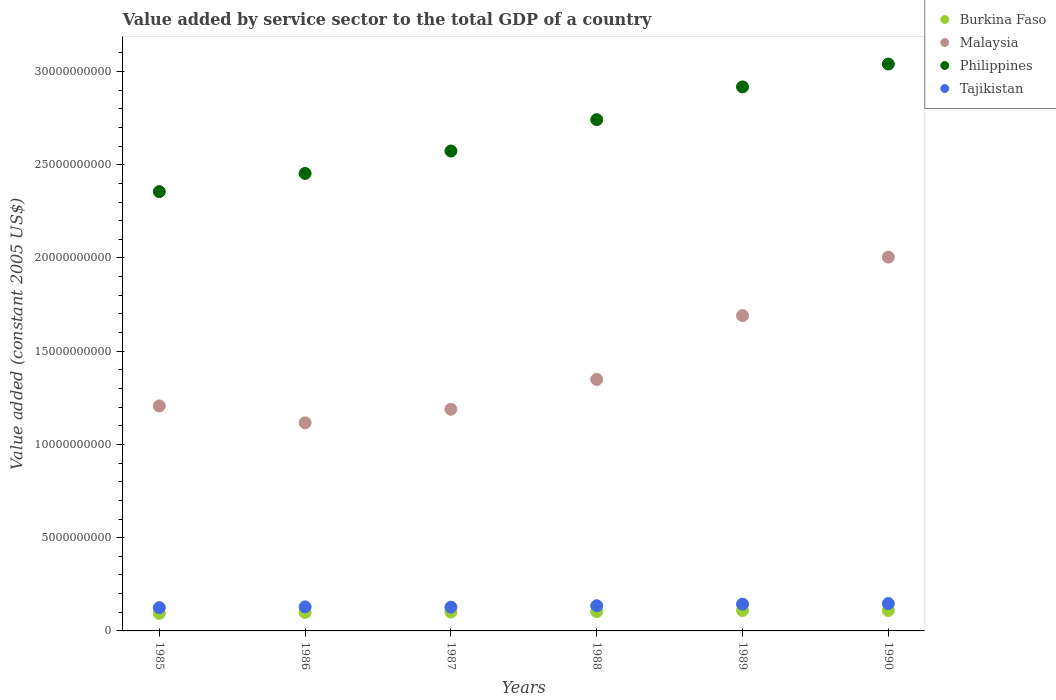Is the number of dotlines equal to the number of legend labels?
Your answer should be very brief. Yes. What is the value added by service sector in Philippines in 1985?
Provide a short and direct response. 2.36e+1. Across all years, what is the maximum value added by service sector in Philippines?
Offer a terse response. 3.04e+1. Across all years, what is the minimum value added by service sector in Tajikistan?
Your response must be concise. 1.25e+09. In which year was the value added by service sector in Tajikistan maximum?
Your answer should be compact. 1990. In which year was the value added by service sector in Philippines minimum?
Ensure brevity in your answer.  1985. What is the total value added by service sector in Burkina Faso in the graph?
Ensure brevity in your answer.  6.17e+09. What is the difference between the value added by service sector in Philippines in 1985 and that in 1989?
Your answer should be compact. -5.62e+09. What is the difference between the value added by service sector in Tajikistan in 1985 and the value added by service sector in Philippines in 1988?
Offer a terse response. -2.62e+1. What is the average value added by service sector in Tajikistan per year?
Provide a short and direct response. 1.34e+09. In the year 1988, what is the difference between the value added by service sector in Tajikistan and value added by service sector in Philippines?
Offer a terse response. -2.61e+1. In how many years, is the value added by service sector in Burkina Faso greater than 13000000000 US$?
Your response must be concise. 0. What is the ratio of the value added by service sector in Philippines in 1986 to that in 1987?
Provide a short and direct response. 0.95. Is the value added by service sector in Malaysia in 1985 less than that in 1990?
Your answer should be very brief. Yes. What is the difference between the highest and the second highest value added by service sector in Malaysia?
Make the answer very short. 3.14e+09. What is the difference between the highest and the lowest value added by service sector in Philippines?
Offer a terse response. 6.84e+09. Is it the case that in every year, the sum of the value added by service sector in Philippines and value added by service sector in Burkina Faso  is greater than the value added by service sector in Malaysia?
Give a very brief answer. Yes. Does the value added by service sector in Tajikistan monotonically increase over the years?
Your answer should be very brief. No. How many years are there in the graph?
Keep it short and to the point. 6. What is the difference between two consecutive major ticks on the Y-axis?
Provide a succinct answer. 5.00e+09. How many legend labels are there?
Give a very brief answer. 4. How are the legend labels stacked?
Your answer should be compact. Vertical. What is the title of the graph?
Make the answer very short. Value added by service sector to the total GDP of a country. Does "New Caledonia" appear as one of the legend labels in the graph?
Keep it short and to the point. No. What is the label or title of the Y-axis?
Your answer should be compact. Value added (constant 2005 US$). What is the Value added (constant 2005 US$) in Burkina Faso in 1985?
Offer a terse response. 9.41e+08. What is the Value added (constant 2005 US$) of Malaysia in 1985?
Ensure brevity in your answer.  1.21e+1. What is the Value added (constant 2005 US$) of Philippines in 1985?
Your answer should be compact. 2.36e+1. What is the Value added (constant 2005 US$) of Tajikistan in 1985?
Provide a short and direct response. 1.25e+09. What is the Value added (constant 2005 US$) in Burkina Faso in 1986?
Provide a succinct answer. 9.91e+08. What is the Value added (constant 2005 US$) of Malaysia in 1986?
Your response must be concise. 1.12e+1. What is the Value added (constant 2005 US$) in Philippines in 1986?
Ensure brevity in your answer.  2.45e+1. What is the Value added (constant 2005 US$) of Tajikistan in 1986?
Offer a terse response. 1.29e+09. What is the Value added (constant 2005 US$) in Burkina Faso in 1987?
Keep it short and to the point. 1.01e+09. What is the Value added (constant 2005 US$) in Malaysia in 1987?
Provide a succinct answer. 1.19e+1. What is the Value added (constant 2005 US$) of Philippines in 1987?
Keep it short and to the point. 2.57e+1. What is the Value added (constant 2005 US$) of Tajikistan in 1987?
Offer a very short reply. 1.28e+09. What is the Value added (constant 2005 US$) of Burkina Faso in 1988?
Keep it short and to the point. 1.04e+09. What is the Value added (constant 2005 US$) of Malaysia in 1988?
Give a very brief answer. 1.35e+1. What is the Value added (constant 2005 US$) in Philippines in 1988?
Ensure brevity in your answer.  2.74e+1. What is the Value added (constant 2005 US$) of Tajikistan in 1988?
Provide a succinct answer. 1.35e+09. What is the Value added (constant 2005 US$) of Burkina Faso in 1989?
Provide a short and direct response. 1.09e+09. What is the Value added (constant 2005 US$) in Malaysia in 1989?
Your answer should be compact. 1.69e+1. What is the Value added (constant 2005 US$) of Philippines in 1989?
Your answer should be very brief. 2.92e+1. What is the Value added (constant 2005 US$) in Tajikistan in 1989?
Give a very brief answer. 1.44e+09. What is the Value added (constant 2005 US$) of Burkina Faso in 1990?
Provide a short and direct response. 1.09e+09. What is the Value added (constant 2005 US$) in Malaysia in 1990?
Give a very brief answer. 2.00e+1. What is the Value added (constant 2005 US$) of Philippines in 1990?
Offer a terse response. 3.04e+1. What is the Value added (constant 2005 US$) in Tajikistan in 1990?
Your answer should be compact. 1.47e+09. Across all years, what is the maximum Value added (constant 2005 US$) in Burkina Faso?
Offer a terse response. 1.09e+09. Across all years, what is the maximum Value added (constant 2005 US$) in Malaysia?
Provide a short and direct response. 2.00e+1. Across all years, what is the maximum Value added (constant 2005 US$) of Philippines?
Provide a short and direct response. 3.04e+1. Across all years, what is the maximum Value added (constant 2005 US$) in Tajikistan?
Provide a succinct answer. 1.47e+09. Across all years, what is the minimum Value added (constant 2005 US$) in Burkina Faso?
Your answer should be compact. 9.41e+08. Across all years, what is the minimum Value added (constant 2005 US$) in Malaysia?
Your answer should be very brief. 1.12e+1. Across all years, what is the minimum Value added (constant 2005 US$) in Philippines?
Provide a succinct answer. 2.36e+1. Across all years, what is the minimum Value added (constant 2005 US$) in Tajikistan?
Make the answer very short. 1.25e+09. What is the total Value added (constant 2005 US$) in Burkina Faso in the graph?
Your answer should be very brief. 6.17e+09. What is the total Value added (constant 2005 US$) of Malaysia in the graph?
Give a very brief answer. 8.56e+1. What is the total Value added (constant 2005 US$) in Philippines in the graph?
Make the answer very short. 1.61e+11. What is the total Value added (constant 2005 US$) of Tajikistan in the graph?
Give a very brief answer. 8.07e+09. What is the difference between the Value added (constant 2005 US$) in Burkina Faso in 1985 and that in 1986?
Offer a very short reply. -4.99e+07. What is the difference between the Value added (constant 2005 US$) of Malaysia in 1985 and that in 1986?
Make the answer very short. 9.03e+08. What is the difference between the Value added (constant 2005 US$) of Philippines in 1985 and that in 1986?
Your answer should be compact. -9.74e+08. What is the difference between the Value added (constant 2005 US$) of Tajikistan in 1985 and that in 1986?
Make the answer very short. -4.25e+07. What is the difference between the Value added (constant 2005 US$) of Burkina Faso in 1985 and that in 1987?
Offer a very short reply. -7.12e+07. What is the difference between the Value added (constant 2005 US$) in Malaysia in 1985 and that in 1987?
Ensure brevity in your answer.  1.76e+08. What is the difference between the Value added (constant 2005 US$) in Philippines in 1985 and that in 1987?
Your answer should be very brief. -2.18e+09. What is the difference between the Value added (constant 2005 US$) of Tajikistan in 1985 and that in 1987?
Your response must be concise. -2.70e+07. What is the difference between the Value added (constant 2005 US$) of Burkina Faso in 1985 and that in 1988?
Give a very brief answer. -9.63e+07. What is the difference between the Value added (constant 2005 US$) of Malaysia in 1985 and that in 1988?
Your response must be concise. -1.42e+09. What is the difference between the Value added (constant 2005 US$) of Philippines in 1985 and that in 1988?
Your answer should be very brief. -3.86e+09. What is the difference between the Value added (constant 2005 US$) of Tajikistan in 1985 and that in 1988?
Offer a terse response. -1.01e+08. What is the difference between the Value added (constant 2005 US$) of Burkina Faso in 1985 and that in 1989?
Your response must be concise. -1.53e+08. What is the difference between the Value added (constant 2005 US$) of Malaysia in 1985 and that in 1989?
Offer a terse response. -4.85e+09. What is the difference between the Value added (constant 2005 US$) in Philippines in 1985 and that in 1989?
Keep it short and to the point. -5.62e+09. What is the difference between the Value added (constant 2005 US$) in Tajikistan in 1985 and that in 1989?
Keep it short and to the point. -1.87e+08. What is the difference between the Value added (constant 2005 US$) of Burkina Faso in 1985 and that in 1990?
Give a very brief answer. -1.51e+08. What is the difference between the Value added (constant 2005 US$) of Malaysia in 1985 and that in 1990?
Your response must be concise. -7.98e+09. What is the difference between the Value added (constant 2005 US$) in Philippines in 1985 and that in 1990?
Provide a short and direct response. -6.84e+09. What is the difference between the Value added (constant 2005 US$) of Tajikistan in 1985 and that in 1990?
Your answer should be compact. -2.19e+08. What is the difference between the Value added (constant 2005 US$) in Burkina Faso in 1986 and that in 1987?
Your response must be concise. -2.14e+07. What is the difference between the Value added (constant 2005 US$) in Malaysia in 1986 and that in 1987?
Ensure brevity in your answer.  -7.26e+08. What is the difference between the Value added (constant 2005 US$) in Philippines in 1986 and that in 1987?
Your response must be concise. -1.20e+09. What is the difference between the Value added (constant 2005 US$) in Tajikistan in 1986 and that in 1987?
Provide a succinct answer. 1.55e+07. What is the difference between the Value added (constant 2005 US$) of Burkina Faso in 1986 and that in 1988?
Provide a short and direct response. -4.64e+07. What is the difference between the Value added (constant 2005 US$) of Malaysia in 1986 and that in 1988?
Ensure brevity in your answer.  -2.33e+09. What is the difference between the Value added (constant 2005 US$) in Philippines in 1986 and that in 1988?
Keep it short and to the point. -2.88e+09. What is the difference between the Value added (constant 2005 US$) in Tajikistan in 1986 and that in 1988?
Give a very brief answer. -5.85e+07. What is the difference between the Value added (constant 2005 US$) in Burkina Faso in 1986 and that in 1989?
Your answer should be very brief. -1.03e+08. What is the difference between the Value added (constant 2005 US$) in Malaysia in 1986 and that in 1989?
Ensure brevity in your answer.  -5.75e+09. What is the difference between the Value added (constant 2005 US$) in Philippines in 1986 and that in 1989?
Your answer should be compact. -4.64e+09. What is the difference between the Value added (constant 2005 US$) of Tajikistan in 1986 and that in 1989?
Give a very brief answer. -1.45e+08. What is the difference between the Value added (constant 2005 US$) in Burkina Faso in 1986 and that in 1990?
Your answer should be very brief. -1.02e+08. What is the difference between the Value added (constant 2005 US$) of Malaysia in 1986 and that in 1990?
Make the answer very short. -8.89e+09. What is the difference between the Value added (constant 2005 US$) of Philippines in 1986 and that in 1990?
Provide a short and direct response. -5.87e+09. What is the difference between the Value added (constant 2005 US$) in Tajikistan in 1986 and that in 1990?
Provide a short and direct response. -1.76e+08. What is the difference between the Value added (constant 2005 US$) of Burkina Faso in 1987 and that in 1988?
Your response must be concise. -2.50e+07. What is the difference between the Value added (constant 2005 US$) in Malaysia in 1987 and that in 1988?
Provide a short and direct response. -1.60e+09. What is the difference between the Value added (constant 2005 US$) in Philippines in 1987 and that in 1988?
Your response must be concise. -1.68e+09. What is the difference between the Value added (constant 2005 US$) in Tajikistan in 1987 and that in 1988?
Offer a very short reply. -7.40e+07. What is the difference between the Value added (constant 2005 US$) in Burkina Faso in 1987 and that in 1989?
Your answer should be compact. -8.15e+07. What is the difference between the Value added (constant 2005 US$) of Malaysia in 1987 and that in 1989?
Offer a very short reply. -5.02e+09. What is the difference between the Value added (constant 2005 US$) of Philippines in 1987 and that in 1989?
Ensure brevity in your answer.  -3.44e+09. What is the difference between the Value added (constant 2005 US$) in Tajikistan in 1987 and that in 1989?
Provide a short and direct response. -1.60e+08. What is the difference between the Value added (constant 2005 US$) of Burkina Faso in 1987 and that in 1990?
Provide a short and direct response. -8.02e+07. What is the difference between the Value added (constant 2005 US$) in Malaysia in 1987 and that in 1990?
Keep it short and to the point. -8.16e+09. What is the difference between the Value added (constant 2005 US$) in Philippines in 1987 and that in 1990?
Provide a short and direct response. -4.66e+09. What is the difference between the Value added (constant 2005 US$) of Tajikistan in 1987 and that in 1990?
Offer a very short reply. -1.92e+08. What is the difference between the Value added (constant 2005 US$) of Burkina Faso in 1988 and that in 1989?
Your answer should be compact. -5.65e+07. What is the difference between the Value added (constant 2005 US$) of Malaysia in 1988 and that in 1989?
Give a very brief answer. -3.42e+09. What is the difference between the Value added (constant 2005 US$) of Philippines in 1988 and that in 1989?
Give a very brief answer. -1.76e+09. What is the difference between the Value added (constant 2005 US$) in Tajikistan in 1988 and that in 1989?
Your response must be concise. -8.64e+07. What is the difference between the Value added (constant 2005 US$) of Burkina Faso in 1988 and that in 1990?
Your answer should be compact. -5.52e+07. What is the difference between the Value added (constant 2005 US$) in Malaysia in 1988 and that in 1990?
Offer a very short reply. -6.56e+09. What is the difference between the Value added (constant 2005 US$) in Philippines in 1988 and that in 1990?
Give a very brief answer. -2.98e+09. What is the difference between the Value added (constant 2005 US$) of Tajikistan in 1988 and that in 1990?
Your answer should be compact. -1.18e+08. What is the difference between the Value added (constant 2005 US$) in Burkina Faso in 1989 and that in 1990?
Your answer should be very brief. 1.32e+06. What is the difference between the Value added (constant 2005 US$) in Malaysia in 1989 and that in 1990?
Provide a succinct answer. -3.14e+09. What is the difference between the Value added (constant 2005 US$) in Philippines in 1989 and that in 1990?
Provide a short and direct response. -1.23e+09. What is the difference between the Value added (constant 2005 US$) of Tajikistan in 1989 and that in 1990?
Keep it short and to the point. -3.16e+07. What is the difference between the Value added (constant 2005 US$) in Burkina Faso in 1985 and the Value added (constant 2005 US$) in Malaysia in 1986?
Your answer should be very brief. -1.02e+1. What is the difference between the Value added (constant 2005 US$) of Burkina Faso in 1985 and the Value added (constant 2005 US$) of Philippines in 1986?
Offer a terse response. -2.36e+1. What is the difference between the Value added (constant 2005 US$) in Burkina Faso in 1985 and the Value added (constant 2005 US$) in Tajikistan in 1986?
Your response must be concise. -3.50e+08. What is the difference between the Value added (constant 2005 US$) in Malaysia in 1985 and the Value added (constant 2005 US$) in Philippines in 1986?
Your answer should be very brief. -1.25e+1. What is the difference between the Value added (constant 2005 US$) in Malaysia in 1985 and the Value added (constant 2005 US$) in Tajikistan in 1986?
Provide a succinct answer. 1.08e+1. What is the difference between the Value added (constant 2005 US$) of Philippines in 1985 and the Value added (constant 2005 US$) of Tajikistan in 1986?
Your answer should be compact. 2.23e+1. What is the difference between the Value added (constant 2005 US$) in Burkina Faso in 1985 and the Value added (constant 2005 US$) in Malaysia in 1987?
Provide a succinct answer. -1.09e+1. What is the difference between the Value added (constant 2005 US$) of Burkina Faso in 1985 and the Value added (constant 2005 US$) of Philippines in 1987?
Ensure brevity in your answer.  -2.48e+1. What is the difference between the Value added (constant 2005 US$) in Burkina Faso in 1985 and the Value added (constant 2005 US$) in Tajikistan in 1987?
Keep it short and to the point. -3.35e+08. What is the difference between the Value added (constant 2005 US$) in Malaysia in 1985 and the Value added (constant 2005 US$) in Philippines in 1987?
Make the answer very short. -1.37e+1. What is the difference between the Value added (constant 2005 US$) of Malaysia in 1985 and the Value added (constant 2005 US$) of Tajikistan in 1987?
Make the answer very short. 1.08e+1. What is the difference between the Value added (constant 2005 US$) of Philippines in 1985 and the Value added (constant 2005 US$) of Tajikistan in 1987?
Keep it short and to the point. 2.23e+1. What is the difference between the Value added (constant 2005 US$) of Burkina Faso in 1985 and the Value added (constant 2005 US$) of Malaysia in 1988?
Keep it short and to the point. -1.25e+1. What is the difference between the Value added (constant 2005 US$) of Burkina Faso in 1985 and the Value added (constant 2005 US$) of Philippines in 1988?
Offer a very short reply. -2.65e+1. What is the difference between the Value added (constant 2005 US$) of Burkina Faso in 1985 and the Value added (constant 2005 US$) of Tajikistan in 1988?
Ensure brevity in your answer.  -4.09e+08. What is the difference between the Value added (constant 2005 US$) of Malaysia in 1985 and the Value added (constant 2005 US$) of Philippines in 1988?
Offer a terse response. -1.54e+1. What is the difference between the Value added (constant 2005 US$) of Malaysia in 1985 and the Value added (constant 2005 US$) of Tajikistan in 1988?
Ensure brevity in your answer.  1.07e+1. What is the difference between the Value added (constant 2005 US$) in Philippines in 1985 and the Value added (constant 2005 US$) in Tajikistan in 1988?
Keep it short and to the point. 2.22e+1. What is the difference between the Value added (constant 2005 US$) in Burkina Faso in 1985 and the Value added (constant 2005 US$) in Malaysia in 1989?
Provide a succinct answer. -1.60e+1. What is the difference between the Value added (constant 2005 US$) of Burkina Faso in 1985 and the Value added (constant 2005 US$) of Philippines in 1989?
Your response must be concise. -2.82e+1. What is the difference between the Value added (constant 2005 US$) of Burkina Faso in 1985 and the Value added (constant 2005 US$) of Tajikistan in 1989?
Provide a short and direct response. -4.95e+08. What is the difference between the Value added (constant 2005 US$) in Malaysia in 1985 and the Value added (constant 2005 US$) in Philippines in 1989?
Your response must be concise. -1.71e+1. What is the difference between the Value added (constant 2005 US$) of Malaysia in 1985 and the Value added (constant 2005 US$) of Tajikistan in 1989?
Make the answer very short. 1.06e+1. What is the difference between the Value added (constant 2005 US$) in Philippines in 1985 and the Value added (constant 2005 US$) in Tajikistan in 1989?
Your answer should be compact. 2.21e+1. What is the difference between the Value added (constant 2005 US$) in Burkina Faso in 1985 and the Value added (constant 2005 US$) in Malaysia in 1990?
Provide a succinct answer. -1.91e+1. What is the difference between the Value added (constant 2005 US$) in Burkina Faso in 1985 and the Value added (constant 2005 US$) in Philippines in 1990?
Your answer should be compact. -2.95e+1. What is the difference between the Value added (constant 2005 US$) in Burkina Faso in 1985 and the Value added (constant 2005 US$) in Tajikistan in 1990?
Provide a short and direct response. -5.27e+08. What is the difference between the Value added (constant 2005 US$) in Malaysia in 1985 and the Value added (constant 2005 US$) in Philippines in 1990?
Make the answer very short. -1.83e+1. What is the difference between the Value added (constant 2005 US$) of Malaysia in 1985 and the Value added (constant 2005 US$) of Tajikistan in 1990?
Your answer should be very brief. 1.06e+1. What is the difference between the Value added (constant 2005 US$) in Philippines in 1985 and the Value added (constant 2005 US$) in Tajikistan in 1990?
Provide a short and direct response. 2.21e+1. What is the difference between the Value added (constant 2005 US$) in Burkina Faso in 1986 and the Value added (constant 2005 US$) in Malaysia in 1987?
Give a very brief answer. -1.09e+1. What is the difference between the Value added (constant 2005 US$) of Burkina Faso in 1986 and the Value added (constant 2005 US$) of Philippines in 1987?
Provide a succinct answer. -2.47e+1. What is the difference between the Value added (constant 2005 US$) of Burkina Faso in 1986 and the Value added (constant 2005 US$) of Tajikistan in 1987?
Provide a succinct answer. -2.85e+08. What is the difference between the Value added (constant 2005 US$) of Malaysia in 1986 and the Value added (constant 2005 US$) of Philippines in 1987?
Your response must be concise. -1.46e+1. What is the difference between the Value added (constant 2005 US$) of Malaysia in 1986 and the Value added (constant 2005 US$) of Tajikistan in 1987?
Your answer should be compact. 9.89e+09. What is the difference between the Value added (constant 2005 US$) in Philippines in 1986 and the Value added (constant 2005 US$) in Tajikistan in 1987?
Make the answer very short. 2.33e+1. What is the difference between the Value added (constant 2005 US$) of Burkina Faso in 1986 and the Value added (constant 2005 US$) of Malaysia in 1988?
Offer a very short reply. -1.25e+1. What is the difference between the Value added (constant 2005 US$) of Burkina Faso in 1986 and the Value added (constant 2005 US$) of Philippines in 1988?
Provide a succinct answer. -2.64e+1. What is the difference between the Value added (constant 2005 US$) of Burkina Faso in 1986 and the Value added (constant 2005 US$) of Tajikistan in 1988?
Your answer should be compact. -3.59e+08. What is the difference between the Value added (constant 2005 US$) in Malaysia in 1986 and the Value added (constant 2005 US$) in Philippines in 1988?
Offer a terse response. -1.63e+1. What is the difference between the Value added (constant 2005 US$) of Malaysia in 1986 and the Value added (constant 2005 US$) of Tajikistan in 1988?
Keep it short and to the point. 9.81e+09. What is the difference between the Value added (constant 2005 US$) in Philippines in 1986 and the Value added (constant 2005 US$) in Tajikistan in 1988?
Ensure brevity in your answer.  2.32e+1. What is the difference between the Value added (constant 2005 US$) in Burkina Faso in 1986 and the Value added (constant 2005 US$) in Malaysia in 1989?
Provide a short and direct response. -1.59e+1. What is the difference between the Value added (constant 2005 US$) of Burkina Faso in 1986 and the Value added (constant 2005 US$) of Philippines in 1989?
Offer a terse response. -2.82e+1. What is the difference between the Value added (constant 2005 US$) in Burkina Faso in 1986 and the Value added (constant 2005 US$) in Tajikistan in 1989?
Provide a short and direct response. -4.45e+08. What is the difference between the Value added (constant 2005 US$) in Malaysia in 1986 and the Value added (constant 2005 US$) in Philippines in 1989?
Keep it short and to the point. -1.80e+1. What is the difference between the Value added (constant 2005 US$) of Malaysia in 1986 and the Value added (constant 2005 US$) of Tajikistan in 1989?
Offer a very short reply. 9.73e+09. What is the difference between the Value added (constant 2005 US$) of Philippines in 1986 and the Value added (constant 2005 US$) of Tajikistan in 1989?
Offer a very short reply. 2.31e+1. What is the difference between the Value added (constant 2005 US$) of Burkina Faso in 1986 and the Value added (constant 2005 US$) of Malaysia in 1990?
Your answer should be compact. -1.91e+1. What is the difference between the Value added (constant 2005 US$) of Burkina Faso in 1986 and the Value added (constant 2005 US$) of Philippines in 1990?
Provide a short and direct response. -2.94e+1. What is the difference between the Value added (constant 2005 US$) of Burkina Faso in 1986 and the Value added (constant 2005 US$) of Tajikistan in 1990?
Provide a short and direct response. -4.77e+08. What is the difference between the Value added (constant 2005 US$) of Malaysia in 1986 and the Value added (constant 2005 US$) of Philippines in 1990?
Provide a succinct answer. -1.92e+1. What is the difference between the Value added (constant 2005 US$) in Malaysia in 1986 and the Value added (constant 2005 US$) in Tajikistan in 1990?
Ensure brevity in your answer.  9.69e+09. What is the difference between the Value added (constant 2005 US$) of Philippines in 1986 and the Value added (constant 2005 US$) of Tajikistan in 1990?
Your answer should be compact. 2.31e+1. What is the difference between the Value added (constant 2005 US$) in Burkina Faso in 1987 and the Value added (constant 2005 US$) in Malaysia in 1988?
Keep it short and to the point. -1.25e+1. What is the difference between the Value added (constant 2005 US$) in Burkina Faso in 1987 and the Value added (constant 2005 US$) in Philippines in 1988?
Provide a succinct answer. -2.64e+1. What is the difference between the Value added (constant 2005 US$) of Burkina Faso in 1987 and the Value added (constant 2005 US$) of Tajikistan in 1988?
Your answer should be very brief. -3.38e+08. What is the difference between the Value added (constant 2005 US$) in Malaysia in 1987 and the Value added (constant 2005 US$) in Philippines in 1988?
Make the answer very short. -1.55e+1. What is the difference between the Value added (constant 2005 US$) in Malaysia in 1987 and the Value added (constant 2005 US$) in Tajikistan in 1988?
Provide a short and direct response. 1.05e+1. What is the difference between the Value added (constant 2005 US$) in Philippines in 1987 and the Value added (constant 2005 US$) in Tajikistan in 1988?
Offer a very short reply. 2.44e+1. What is the difference between the Value added (constant 2005 US$) of Burkina Faso in 1987 and the Value added (constant 2005 US$) of Malaysia in 1989?
Give a very brief answer. -1.59e+1. What is the difference between the Value added (constant 2005 US$) in Burkina Faso in 1987 and the Value added (constant 2005 US$) in Philippines in 1989?
Provide a succinct answer. -2.82e+1. What is the difference between the Value added (constant 2005 US$) in Burkina Faso in 1987 and the Value added (constant 2005 US$) in Tajikistan in 1989?
Offer a terse response. -4.24e+08. What is the difference between the Value added (constant 2005 US$) in Malaysia in 1987 and the Value added (constant 2005 US$) in Philippines in 1989?
Your answer should be very brief. -1.73e+1. What is the difference between the Value added (constant 2005 US$) of Malaysia in 1987 and the Value added (constant 2005 US$) of Tajikistan in 1989?
Make the answer very short. 1.05e+1. What is the difference between the Value added (constant 2005 US$) in Philippines in 1987 and the Value added (constant 2005 US$) in Tajikistan in 1989?
Your response must be concise. 2.43e+1. What is the difference between the Value added (constant 2005 US$) in Burkina Faso in 1987 and the Value added (constant 2005 US$) in Malaysia in 1990?
Your answer should be very brief. -1.90e+1. What is the difference between the Value added (constant 2005 US$) of Burkina Faso in 1987 and the Value added (constant 2005 US$) of Philippines in 1990?
Your answer should be very brief. -2.94e+1. What is the difference between the Value added (constant 2005 US$) in Burkina Faso in 1987 and the Value added (constant 2005 US$) in Tajikistan in 1990?
Offer a terse response. -4.56e+08. What is the difference between the Value added (constant 2005 US$) in Malaysia in 1987 and the Value added (constant 2005 US$) in Philippines in 1990?
Your response must be concise. -1.85e+1. What is the difference between the Value added (constant 2005 US$) of Malaysia in 1987 and the Value added (constant 2005 US$) of Tajikistan in 1990?
Ensure brevity in your answer.  1.04e+1. What is the difference between the Value added (constant 2005 US$) in Philippines in 1987 and the Value added (constant 2005 US$) in Tajikistan in 1990?
Provide a short and direct response. 2.43e+1. What is the difference between the Value added (constant 2005 US$) of Burkina Faso in 1988 and the Value added (constant 2005 US$) of Malaysia in 1989?
Provide a short and direct response. -1.59e+1. What is the difference between the Value added (constant 2005 US$) of Burkina Faso in 1988 and the Value added (constant 2005 US$) of Philippines in 1989?
Provide a short and direct response. -2.81e+1. What is the difference between the Value added (constant 2005 US$) of Burkina Faso in 1988 and the Value added (constant 2005 US$) of Tajikistan in 1989?
Provide a succinct answer. -3.99e+08. What is the difference between the Value added (constant 2005 US$) of Malaysia in 1988 and the Value added (constant 2005 US$) of Philippines in 1989?
Your answer should be very brief. -1.57e+1. What is the difference between the Value added (constant 2005 US$) in Malaysia in 1988 and the Value added (constant 2005 US$) in Tajikistan in 1989?
Your answer should be compact. 1.21e+1. What is the difference between the Value added (constant 2005 US$) in Philippines in 1988 and the Value added (constant 2005 US$) in Tajikistan in 1989?
Offer a very short reply. 2.60e+1. What is the difference between the Value added (constant 2005 US$) of Burkina Faso in 1988 and the Value added (constant 2005 US$) of Malaysia in 1990?
Give a very brief answer. -1.90e+1. What is the difference between the Value added (constant 2005 US$) of Burkina Faso in 1988 and the Value added (constant 2005 US$) of Philippines in 1990?
Your answer should be compact. -2.94e+1. What is the difference between the Value added (constant 2005 US$) of Burkina Faso in 1988 and the Value added (constant 2005 US$) of Tajikistan in 1990?
Your answer should be very brief. -4.31e+08. What is the difference between the Value added (constant 2005 US$) in Malaysia in 1988 and the Value added (constant 2005 US$) in Philippines in 1990?
Keep it short and to the point. -1.69e+1. What is the difference between the Value added (constant 2005 US$) in Malaysia in 1988 and the Value added (constant 2005 US$) in Tajikistan in 1990?
Keep it short and to the point. 1.20e+1. What is the difference between the Value added (constant 2005 US$) of Philippines in 1988 and the Value added (constant 2005 US$) of Tajikistan in 1990?
Offer a terse response. 2.60e+1. What is the difference between the Value added (constant 2005 US$) of Burkina Faso in 1989 and the Value added (constant 2005 US$) of Malaysia in 1990?
Ensure brevity in your answer.  -1.90e+1. What is the difference between the Value added (constant 2005 US$) of Burkina Faso in 1989 and the Value added (constant 2005 US$) of Philippines in 1990?
Your answer should be very brief. -2.93e+1. What is the difference between the Value added (constant 2005 US$) in Burkina Faso in 1989 and the Value added (constant 2005 US$) in Tajikistan in 1990?
Provide a short and direct response. -3.74e+08. What is the difference between the Value added (constant 2005 US$) in Malaysia in 1989 and the Value added (constant 2005 US$) in Philippines in 1990?
Your answer should be very brief. -1.35e+1. What is the difference between the Value added (constant 2005 US$) in Malaysia in 1989 and the Value added (constant 2005 US$) in Tajikistan in 1990?
Offer a very short reply. 1.54e+1. What is the difference between the Value added (constant 2005 US$) in Philippines in 1989 and the Value added (constant 2005 US$) in Tajikistan in 1990?
Your response must be concise. 2.77e+1. What is the average Value added (constant 2005 US$) in Burkina Faso per year?
Offer a very short reply. 1.03e+09. What is the average Value added (constant 2005 US$) of Malaysia per year?
Make the answer very short. 1.43e+1. What is the average Value added (constant 2005 US$) in Philippines per year?
Give a very brief answer. 2.68e+1. What is the average Value added (constant 2005 US$) in Tajikistan per year?
Ensure brevity in your answer.  1.34e+09. In the year 1985, what is the difference between the Value added (constant 2005 US$) in Burkina Faso and Value added (constant 2005 US$) in Malaysia?
Provide a succinct answer. -1.11e+1. In the year 1985, what is the difference between the Value added (constant 2005 US$) of Burkina Faso and Value added (constant 2005 US$) of Philippines?
Ensure brevity in your answer.  -2.26e+1. In the year 1985, what is the difference between the Value added (constant 2005 US$) of Burkina Faso and Value added (constant 2005 US$) of Tajikistan?
Give a very brief answer. -3.08e+08. In the year 1985, what is the difference between the Value added (constant 2005 US$) in Malaysia and Value added (constant 2005 US$) in Philippines?
Keep it short and to the point. -1.15e+1. In the year 1985, what is the difference between the Value added (constant 2005 US$) in Malaysia and Value added (constant 2005 US$) in Tajikistan?
Give a very brief answer. 1.08e+1. In the year 1985, what is the difference between the Value added (constant 2005 US$) of Philippines and Value added (constant 2005 US$) of Tajikistan?
Your answer should be compact. 2.23e+1. In the year 1986, what is the difference between the Value added (constant 2005 US$) in Burkina Faso and Value added (constant 2005 US$) in Malaysia?
Ensure brevity in your answer.  -1.02e+1. In the year 1986, what is the difference between the Value added (constant 2005 US$) in Burkina Faso and Value added (constant 2005 US$) in Philippines?
Provide a short and direct response. -2.35e+1. In the year 1986, what is the difference between the Value added (constant 2005 US$) of Burkina Faso and Value added (constant 2005 US$) of Tajikistan?
Give a very brief answer. -3.00e+08. In the year 1986, what is the difference between the Value added (constant 2005 US$) of Malaysia and Value added (constant 2005 US$) of Philippines?
Ensure brevity in your answer.  -1.34e+1. In the year 1986, what is the difference between the Value added (constant 2005 US$) in Malaysia and Value added (constant 2005 US$) in Tajikistan?
Provide a succinct answer. 9.87e+09. In the year 1986, what is the difference between the Value added (constant 2005 US$) of Philippines and Value added (constant 2005 US$) of Tajikistan?
Provide a short and direct response. 2.32e+1. In the year 1987, what is the difference between the Value added (constant 2005 US$) in Burkina Faso and Value added (constant 2005 US$) in Malaysia?
Make the answer very short. -1.09e+1. In the year 1987, what is the difference between the Value added (constant 2005 US$) of Burkina Faso and Value added (constant 2005 US$) of Philippines?
Ensure brevity in your answer.  -2.47e+1. In the year 1987, what is the difference between the Value added (constant 2005 US$) in Burkina Faso and Value added (constant 2005 US$) in Tajikistan?
Your answer should be compact. -2.64e+08. In the year 1987, what is the difference between the Value added (constant 2005 US$) of Malaysia and Value added (constant 2005 US$) of Philippines?
Your response must be concise. -1.38e+1. In the year 1987, what is the difference between the Value added (constant 2005 US$) of Malaysia and Value added (constant 2005 US$) of Tajikistan?
Your response must be concise. 1.06e+1. In the year 1987, what is the difference between the Value added (constant 2005 US$) of Philippines and Value added (constant 2005 US$) of Tajikistan?
Keep it short and to the point. 2.45e+1. In the year 1988, what is the difference between the Value added (constant 2005 US$) of Burkina Faso and Value added (constant 2005 US$) of Malaysia?
Provide a short and direct response. -1.25e+1. In the year 1988, what is the difference between the Value added (constant 2005 US$) of Burkina Faso and Value added (constant 2005 US$) of Philippines?
Provide a short and direct response. -2.64e+1. In the year 1988, what is the difference between the Value added (constant 2005 US$) of Burkina Faso and Value added (constant 2005 US$) of Tajikistan?
Your answer should be compact. -3.13e+08. In the year 1988, what is the difference between the Value added (constant 2005 US$) of Malaysia and Value added (constant 2005 US$) of Philippines?
Give a very brief answer. -1.39e+1. In the year 1988, what is the difference between the Value added (constant 2005 US$) of Malaysia and Value added (constant 2005 US$) of Tajikistan?
Your answer should be compact. 1.21e+1. In the year 1988, what is the difference between the Value added (constant 2005 US$) of Philippines and Value added (constant 2005 US$) of Tajikistan?
Make the answer very short. 2.61e+1. In the year 1989, what is the difference between the Value added (constant 2005 US$) of Burkina Faso and Value added (constant 2005 US$) of Malaysia?
Offer a terse response. -1.58e+1. In the year 1989, what is the difference between the Value added (constant 2005 US$) of Burkina Faso and Value added (constant 2005 US$) of Philippines?
Your answer should be very brief. -2.81e+1. In the year 1989, what is the difference between the Value added (constant 2005 US$) of Burkina Faso and Value added (constant 2005 US$) of Tajikistan?
Make the answer very short. -3.42e+08. In the year 1989, what is the difference between the Value added (constant 2005 US$) of Malaysia and Value added (constant 2005 US$) of Philippines?
Ensure brevity in your answer.  -1.23e+1. In the year 1989, what is the difference between the Value added (constant 2005 US$) in Malaysia and Value added (constant 2005 US$) in Tajikistan?
Make the answer very short. 1.55e+1. In the year 1989, what is the difference between the Value added (constant 2005 US$) in Philippines and Value added (constant 2005 US$) in Tajikistan?
Offer a terse response. 2.77e+1. In the year 1990, what is the difference between the Value added (constant 2005 US$) of Burkina Faso and Value added (constant 2005 US$) of Malaysia?
Your answer should be compact. -1.90e+1. In the year 1990, what is the difference between the Value added (constant 2005 US$) in Burkina Faso and Value added (constant 2005 US$) in Philippines?
Ensure brevity in your answer.  -2.93e+1. In the year 1990, what is the difference between the Value added (constant 2005 US$) of Burkina Faso and Value added (constant 2005 US$) of Tajikistan?
Your answer should be very brief. -3.75e+08. In the year 1990, what is the difference between the Value added (constant 2005 US$) in Malaysia and Value added (constant 2005 US$) in Philippines?
Offer a terse response. -1.04e+1. In the year 1990, what is the difference between the Value added (constant 2005 US$) in Malaysia and Value added (constant 2005 US$) in Tajikistan?
Keep it short and to the point. 1.86e+1. In the year 1990, what is the difference between the Value added (constant 2005 US$) of Philippines and Value added (constant 2005 US$) of Tajikistan?
Your answer should be compact. 2.89e+1. What is the ratio of the Value added (constant 2005 US$) of Burkina Faso in 1985 to that in 1986?
Give a very brief answer. 0.95. What is the ratio of the Value added (constant 2005 US$) of Malaysia in 1985 to that in 1986?
Your answer should be very brief. 1.08. What is the ratio of the Value added (constant 2005 US$) in Philippines in 1985 to that in 1986?
Make the answer very short. 0.96. What is the ratio of the Value added (constant 2005 US$) of Tajikistan in 1985 to that in 1986?
Your answer should be very brief. 0.97. What is the ratio of the Value added (constant 2005 US$) of Burkina Faso in 1985 to that in 1987?
Ensure brevity in your answer.  0.93. What is the ratio of the Value added (constant 2005 US$) of Malaysia in 1985 to that in 1987?
Provide a short and direct response. 1.01. What is the ratio of the Value added (constant 2005 US$) of Philippines in 1985 to that in 1987?
Your answer should be compact. 0.92. What is the ratio of the Value added (constant 2005 US$) of Tajikistan in 1985 to that in 1987?
Your answer should be compact. 0.98. What is the ratio of the Value added (constant 2005 US$) in Burkina Faso in 1985 to that in 1988?
Make the answer very short. 0.91. What is the ratio of the Value added (constant 2005 US$) in Malaysia in 1985 to that in 1988?
Make the answer very short. 0.89. What is the ratio of the Value added (constant 2005 US$) in Philippines in 1985 to that in 1988?
Provide a succinct answer. 0.86. What is the ratio of the Value added (constant 2005 US$) of Tajikistan in 1985 to that in 1988?
Provide a short and direct response. 0.93. What is the ratio of the Value added (constant 2005 US$) in Burkina Faso in 1985 to that in 1989?
Offer a very short reply. 0.86. What is the ratio of the Value added (constant 2005 US$) of Malaysia in 1985 to that in 1989?
Offer a terse response. 0.71. What is the ratio of the Value added (constant 2005 US$) of Philippines in 1985 to that in 1989?
Give a very brief answer. 0.81. What is the ratio of the Value added (constant 2005 US$) in Tajikistan in 1985 to that in 1989?
Make the answer very short. 0.87. What is the ratio of the Value added (constant 2005 US$) in Burkina Faso in 1985 to that in 1990?
Ensure brevity in your answer.  0.86. What is the ratio of the Value added (constant 2005 US$) of Malaysia in 1985 to that in 1990?
Make the answer very short. 0.6. What is the ratio of the Value added (constant 2005 US$) in Philippines in 1985 to that in 1990?
Ensure brevity in your answer.  0.78. What is the ratio of the Value added (constant 2005 US$) of Tajikistan in 1985 to that in 1990?
Keep it short and to the point. 0.85. What is the ratio of the Value added (constant 2005 US$) of Burkina Faso in 1986 to that in 1987?
Your answer should be very brief. 0.98. What is the ratio of the Value added (constant 2005 US$) of Malaysia in 1986 to that in 1987?
Provide a short and direct response. 0.94. What is the ratio of the Value added (constant 2005 US$) in Philippines in 1986 to that in 1987?
Make the answer very short. 0.95. What is the ratio of the Value added (constant 2005 US$) in Tajikistan in 1986 to that in 1987?
Make the answer very short. 1.01. What is the ratio of the Value added (constant 2005 US$) of Burkina Faso in 1986 to that in 1988?
Make the answer very short. 0.96. What is the ratio of the Value added (constant 2005 US$) of Malaysia in 1986 to that in 1988?
Ensure brevity in your answer.  0.83. What is the ratio of the Value added (constant 2005 US$) of Philippines in 1986 to that in 1988?
Your answer should be compact. 0.89. What is the ratio of the Value added (constant 2005 US$) in Tajikistan in 1986 to that in 1988?
Ensure brevity in your answer.  0.96. What is the ratio of the Value added (constant 2005 US$) of Burkina Faso in 1986 to that in 1989?
Offer a terse response. 0.91. What is the ratio of the Value added (constant 2005 US$) of Malaysia in 1986 to that in 1989?
Provide a short and direct response. 0.66. What is the ratio of the Value added (constant 2005 US$) of Philippines in 1986 to that in 1989?
Your response must be concise. 0.84. What is the ratio of the Value added (constant 2005 US$) of Tajikistan in 1986 to that in 1989?
Offer a very short reply. 0.9. What is the ratio of the Value added (constant 2005 US$) of Burkina Faso in 1986 to that in 1990?
Provide a succinct answer. 0.91. What is the ratio of the Value added (constant 2005 US$) of Malaysia in 1986 to that in 1990?
Provide a short and direct response. 0.56. What is the ratio of the Value added (constant 2005 US$) in Philippines in 1986 to that in 1990?
Offer a very short reply. 0.81. What is the ratio of the Value added (constant 2005 US$) in Tajikistan in 1986 to that in 1990?
Make the answer very short. 0.88. What is the ratio of the Value added (constant 2005 US$) of Burkina Faso in 1987 to that in 1988?
Ensure brevity in your answer.  0.98. What is the ratio of the Value added (constant 2005 US$) in Malaysia in 1987 to that in 1988?
Make the answer very short. 0.88. What is the ratio of the Value added (constant 2005 US$) of Philippines in 1987 to that in 1988?
Your answer should be very brief. 0.94. What is the ratio of the Value added (constant 2005 US$) in Tajikistan in 1987 to that in 1988?
Offer a terse response. 0.95. What is the ratio of the Value added (constant 2005 US$) of Burkina Faso in 1987 to that in 1989?
Ensure brevity in your answer.  0.93. What is the ratio of the Value added (constant 2005 US$) in Malaysia in 1987 to that in 1989?
Offer a terse response. 0.7. What is the ratio of the Value added (constant 2005 US$) in Philippines in 1987 to that in 1989?
Provide a succinct answer. 0.88. What is the ratio of the Value added (constant 2005 US$) in Tajikistan in 1987 to that in 1989?
Make the answer very short. 0.89. What is the ratio of the Value added (constant 2005 US$) in Burkina Faso in 1987 to that in 1990?
Keep it short and to the point. 0.93. What is the ratio of the Value added (constant 2005 US$) in Malaysia in 1987 to that in 1990?
Give a very brief answer. 0.59. What is the ratio of the Value added (constant 2005 US$) of Philippines in 1987 to that in 1990?
Keep it short and to the point. 0.85. What is the ratio of the Value added (constant 2005 US$) in Tajikistan in 1987 to that in 1990?
Your answer should be very brief. 0.87. What is the ratio of the Value added (constant 2005 US$) of Burkina Faso in 1988 to that in 1989?
Offer a terse response. 0.95. What is the ratio of the Value added (constant 2005 US$) of Malaysia in 1988 to that in 1989?
Your answer should be very brief. 0.8. What is the ratio of the Value added (constant 2005 US$) of Philippines in 1988 to that in 1989?
Your response must be concise. 0.94. What is the ratio of the Value added (constant 2005 US$) of Tajikistan in 1988 to that in 1989?
Provide a succinct answer. 0.94. What is the ratio of the Value added (constant 2005 US$) in Burkina Faso in 1988 to that in 1990?
Your response must be concise. 0.95. What is the ratio of the Value added (constant 2005 US$) in Malaysia in 1988 to that in 1990?
Ensure brevity in your answer.  0.67. What is the ratio of the Value added (constant 2005 US$) in Philippines in 1988 to that in 1990?
Give a very brief answer. 0.9. What is the ratio of the Value added (constant 2005 US$) in Tajikistan in 1988 to that in 1990?
Provide a short and direct response. 0.92. What is the ratio of the Value added (constant 2005 US$) in Malaysia in 1989 to that in 1990?
Offer a terse response. 0.84. What is the ratio of the Value added (constant 2005 US$) in Philippines in 1989 to that in 1990?
Your answer should be very brief. 0.96. What is the ratio of the Value added (constant 2005 US$) of Tajikistan in 1989 to that in 1990?
Your answer should be compact. 0.98. What is the difference between the highest and the second highest Value added (constant 2005 US$) in Burkina Faso?
Make the answer very short. 1.32e+06. What is the difference between the highest and the second highest Value added (constant 2005 US$) in Malaysia?
Your response must be concise. 3.14e+09. What is the difference between the highest and the second highest Value added (constant 2005 US$) in Philippines?
Make the answer very short. 1.23e+09. What is the difference between the highest and the second highest Value added (constant 2005 US$) in Tajikistan?
Your answer should be very brief. 3.16e+07. What is the difference between the highest and the lowest Value added (constant 2005 US$) in Burkina Faso?
Your response must be concise. 1.53e+08. What is the difference between the highest and the lowest Value added (constant 2005 US$) in Malaysia?
Make the answer very short. 8.89e+09. What is the difference between the highest and the lowest Value added (constant 2005 US$) of Philippines?
Make the answer very short. 6.84e+09. What is the difference between the highest and the lowest Value added (constant 2005 US$) of Tajikistan?
Provide a succinct answer. 2.19e+08. 